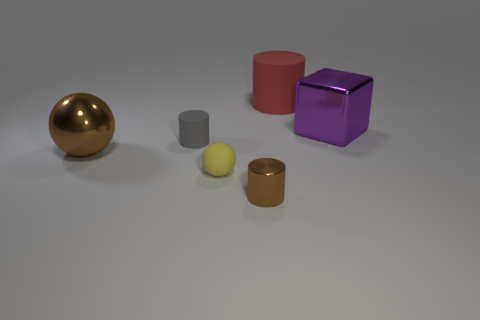What is the small gray cylinder made of?
Ensure brevity in your answer.  Rubber. Is the shape of the big red rubber object the same as the tiny gray matte object?
Give a very brief answer. Yes. Are there any cubes made of the same material as the tiny brown cylinder?
Keep it short and to the point. Yes. What color is the cylinder that is both on the right side of the tiny yellow ball and in front of the red rubber thing?
Ensure brevity in your answer.  Brown. What is the material of the sphere that is on the right side of the tiny gray cylinder?
Make the answer very short. Rubber. Are there any other things of the same shape as the big rubber object?
Your response must be concise. Yes. What number of other objects are the same shape as the large purple object?
Make the answer very short. 0. Does the small metallic thing have the same shape as the rubber thing behind the tiny gray object?
Provide a succinct answer. Yes. What material is the gray thing that is the same shape as the small brown object?
Your answer should be very brief. Rubber. How many big objects are either brown objects or yellow rubber things?
Your answer should be compact. 1. 